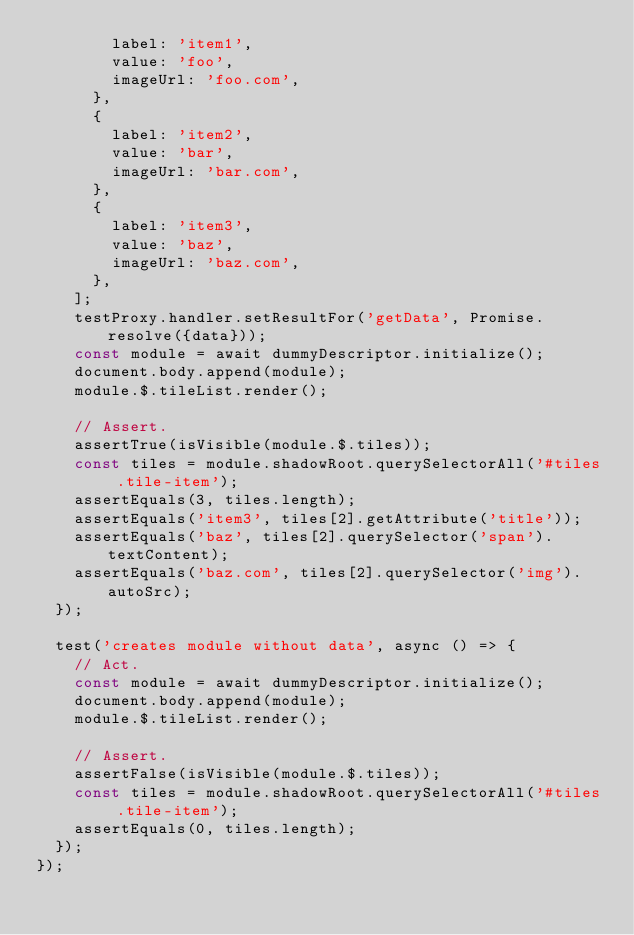Convert code to text. <code><loc_0><loc_0><loc_500><loc_500><_JavaScript_>        label: 'item1',
        value: 'foo',
        imageUrl: 'foo.com',
      },
      {
        label: 'item2',
        value: 'bar',
        imageUrl: 'bar.com',
      },
      {
        label: 'item3',
        value: 'baz',
        imageUrl: 'baz.com',
      },
    ];
    testProxy.handler.setResultFor('getData', Promise.resolve({data}));
    const module = await dummyDescriptor.initialize();
    document.body.append(module);
    module.$.tileList.render();

    // Assert.
    assertTrue(isVisible(module.$.tiles));
    const tiles = module.shadowRoot.querySelectorAll('#tiles .tile-item');
    assertEquals(3, tiles.length);
    assertEquals('item3', tiles[2].getAttribute('title'));
    assertEquals('baz', tiles[2].querySelector('span').textContent);
    assertEquals('baz.com', tiles[2].querySelector('img').autoSrc);
  });

  test('creates module without data', async () => {
    // Act.
    const module = await dummyDescriptor.initialize();
    document.body.append(module);
    module.$.tileList.render();

    // Assert.
    assertFalse(isVisible(module.$.tiles));
    const tiles = module.shadowRoot.querySelectorAll('#tiles .tile-item');
    assertEquals(0, tiles.length);
  });
});
</code> 